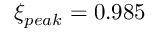Convert formula to latex. <formula><loc_0><loc_0><loc_500><loc_500>\xi _ { p e a k } = 0 . 9 8 5</formula> 